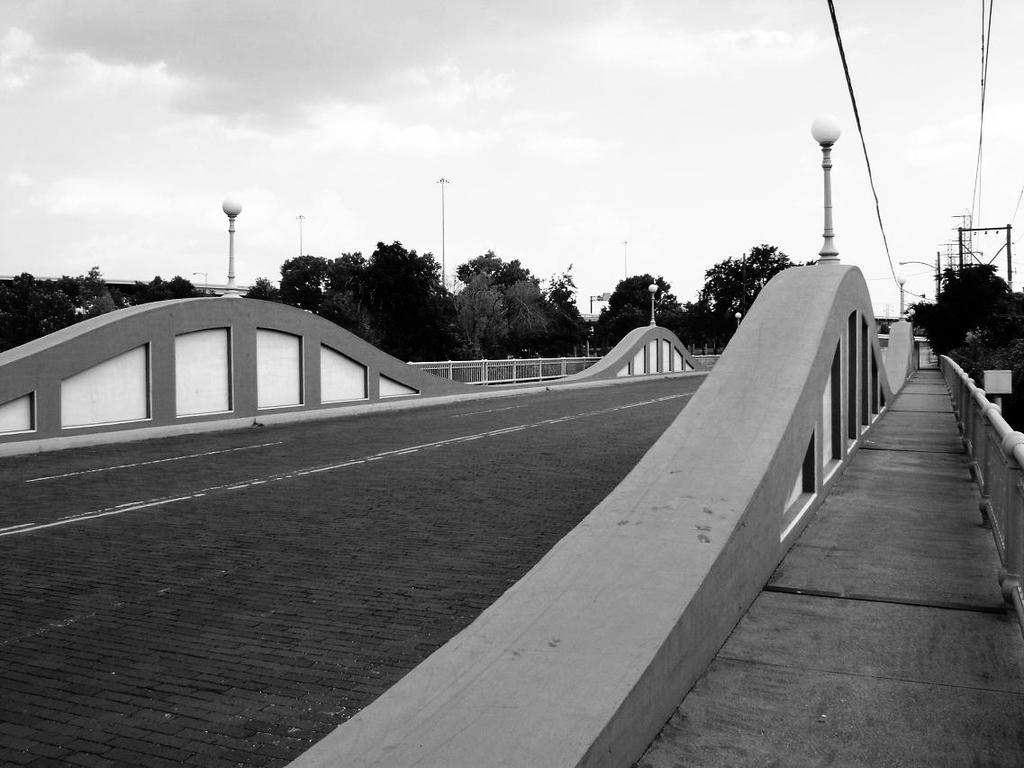What structure can be seen in the image? There is a bridge in the image. What type of vegetation is present in the image? There are trees in the middle of the image. What is visible at the top of the image? The sky is visible at the top of the image. How many brothers are standing on the bridge in the image? There are no people, including brothers, present in the image. What type of light bulb is used to illuminate the bridge in the image? There is no mention of a light bulb or any form of illumination in the image. 